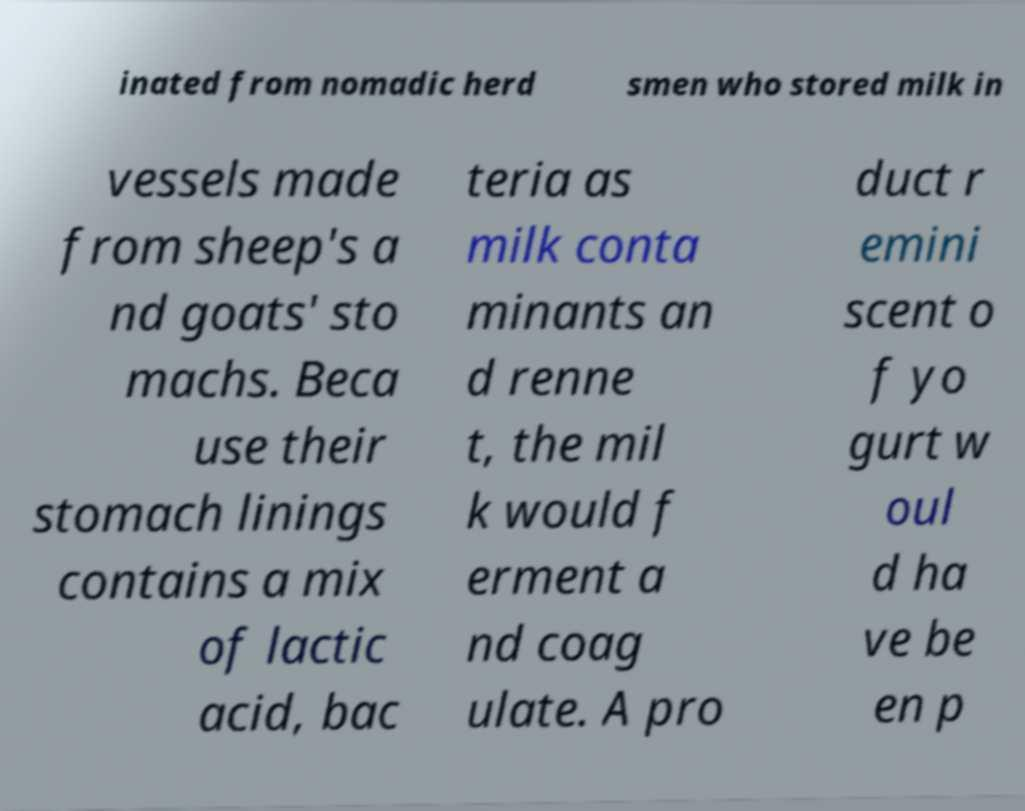Can you read and provide the text displayed in the image?This photo seems to have some interesting text. Can you extract and type it out for me? inated from nomadic herd smen who stored milk in vessels made from sheep's a nd goats' sto machs. Beca use their stomach linings contains a mix of lactic acid, bac teria as milk conta minants an d renne t, the mil k would f erment a nd coag ulate. A pro duct r emini scent o f yo gurt w oul d ha ve be en p 